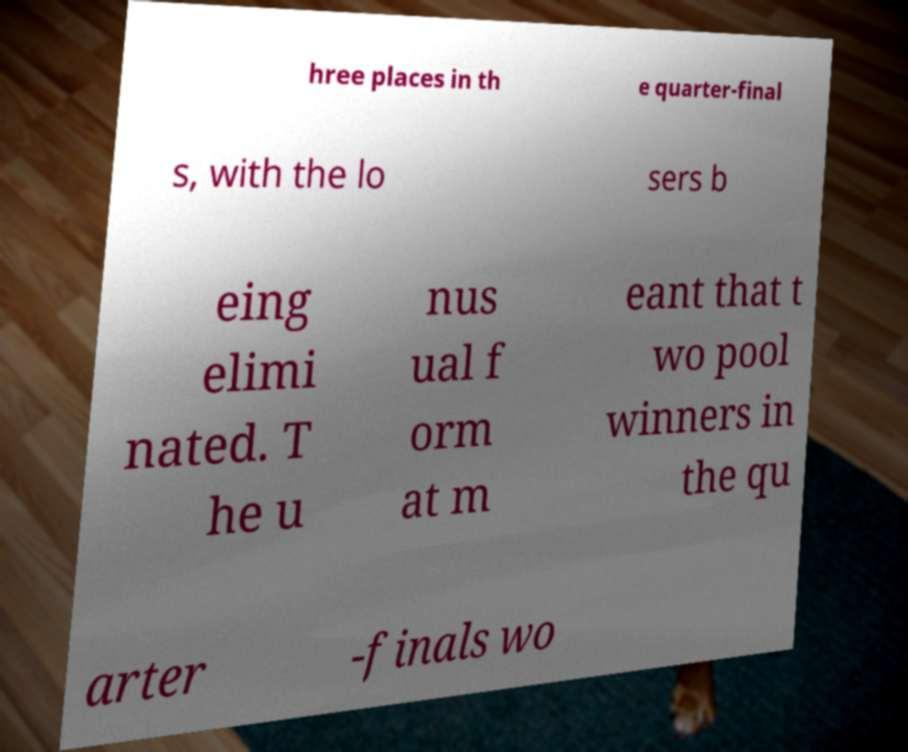Please identify and transcribe the text found in this image. hree places in th e quarter-final s, with the lo sers b eing elimi nated. T he u nus ual f orm at m eant that t wo pool winners in the qu arter -finals wo 